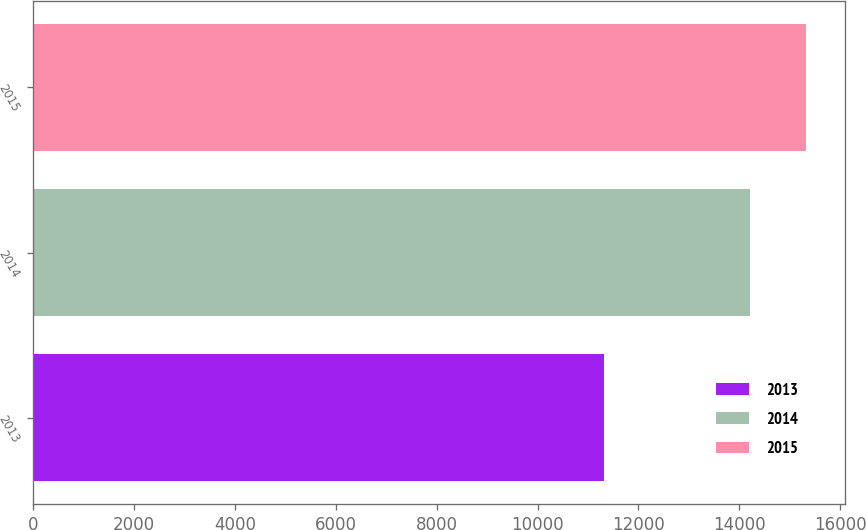<chart> <loc_0><loc_0><loc_500><loc_500><bar_chart><fcel>2013<fcel>2014<fcel>2015<nl><fcel>11321<fcel>14209<fcel>15326<nl></chart> 